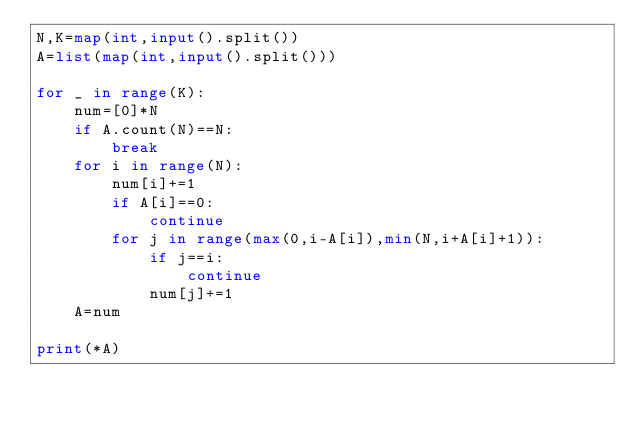<code> <loc_0><loc_0><loc_500><loc_500><_Python_>N,K=map(int,input().split())
A=list(map(int,input().split()))

for _ in range(K):
    num=[0]*N
    if A.count(N)==N:
        break
    for i in range(N):
        num[i]+=1
        if A[i]==0:
            continue
        for j in range(max(0,i-A[i]),min(N,i+A[i]+1)):
            if j==i:
                continue
            num[j]+=1
    A=num

print(*A)</code> 